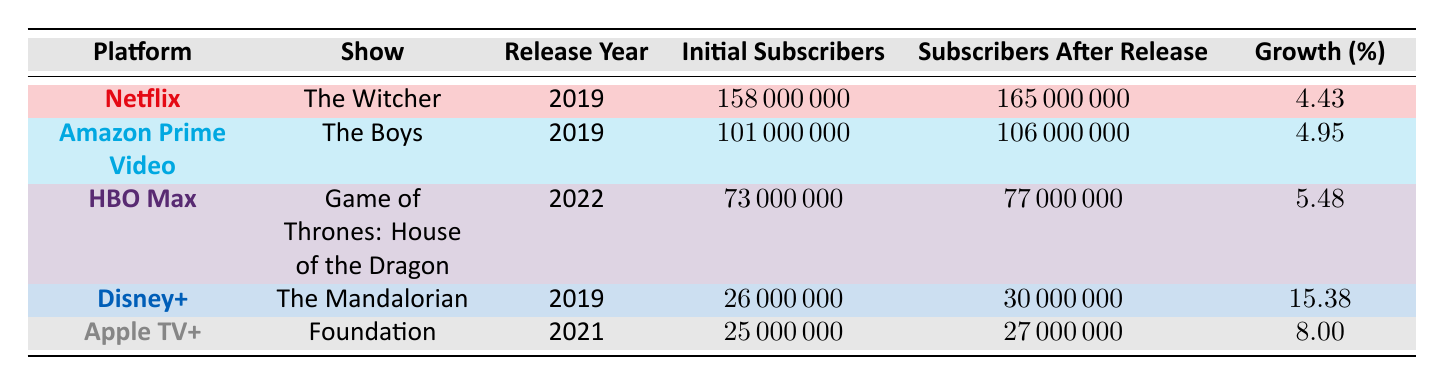What is the initial number of subscribers for Disney+? The table indicates that the initial number of subscribers for Disney+ was 26,000,000, as listed under the "Initial Subscribers" column for that platform.
Answer: 26,000,000 Which show led to the highest percentage growth in subscriptions? Disney+ with The Mandalorian saw the highest percentage growth of 15.38%, which is evident when comparing the "Growth (%)" column.
Answer: The Mandalorian What is the difference in subscriber numbers before and after the release of The Witcher? The initial number of subscribers for Netflix before The Witcher was 158,000,000, and after the release, it was 165,000,000. The difference is calculated as 165,000,000 - 158,000,000 = 7,000,000.
Answer: 7,000,000 Which platforms had a growth percentage greater than 5%? By examining the "Growth (%)" column, HBO Max (5.48%), Disney+ (15.38%), and Apple TV+ (8.00%) all had growth percentages greater than 5%.
Answer: HBO Max, Disney+, Apple TV+ What is the average growth percentage across all platforms listed in the table? To find the average growth percentage, sum all the growth percentages (4.43 + 4.95 + 5.48 + 15.38 + 8.00 = 38.24) and divide by the number of platforms (5). The average growth percentage is 38.24/5 = 7.648.
Answer: 7.648 Did Amazon Prime Video's subscriber growth surpass Netflix's after their respective shows were released? Amazon Prime Video had a growth of 4.95% while Netflix had a growth of 4.43%. Since 4.95% is greater than 4.43%, this statement is true.
Answer: Yes Which platform had the lowest initial subscriber count and what was it? Observing the "Initial Subscribers" column, Apple TV+ had the lowest initial subscriber count at 25,000,000.
Answer: 25,000,000 What is the total number of subscribers across all platforms after their series were released? Adding the "Subscribers After Release" values (165,000,000 + 106,000,000 + 77,000,000 + 30,000,000 + 27,000,000) gives a total of 405,000,000 subscribers across all platforms.
Answer: 405,000,000 